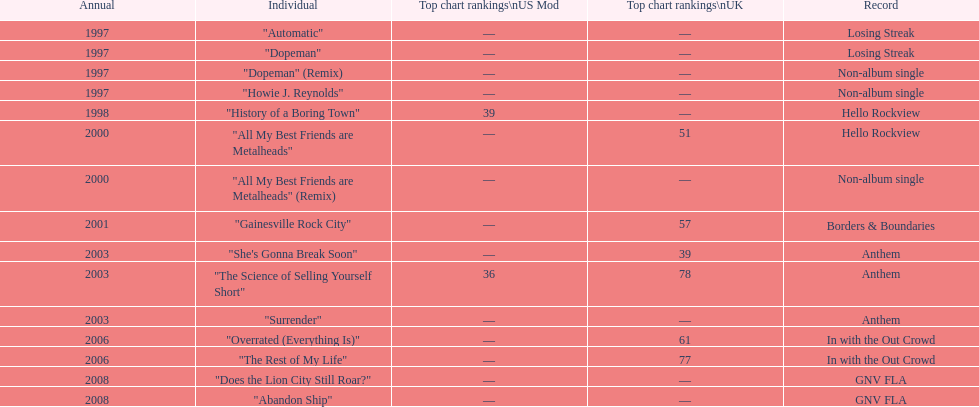Which album had the single automatic? Losing Streak. 